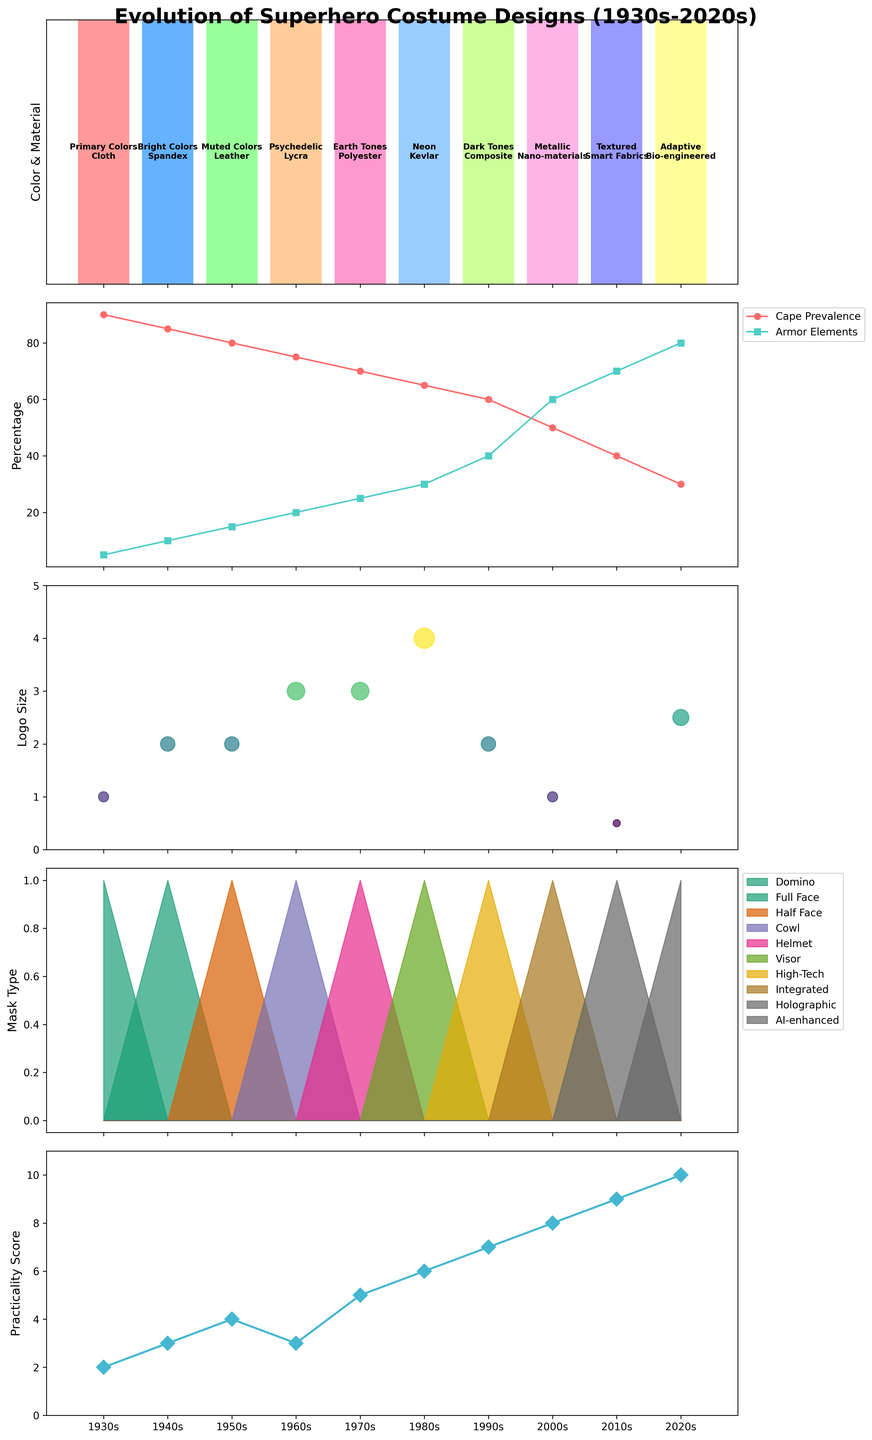How did the cape prevalence change from the 1930s to the 2020s? Observe the trend of the line representing 'Cape Prevalence' in the second subplot. The values start at 90% in the 1930s and decrease gradually by each decade, reaching 30% in the 2020s.
Answer: Decreased from 90% to 30% Which decade saw the highest increase in practical score? Look at the fifth subplot which shows 'Practicality Score'. Identify the decade with the highest rise between two adjacent data points. The practicality score rose most significantly from the 1990s to 2000s, from 7 to 8.
Answer: 1990s to 2000s Between which decades did the armor elements percentage increase the most? Examine the second subplot which shows 'Armor Elements'. The largest increase appears to be between the 1990s and 2000s, jumping from 40% to 60%.
Answer: 1990s to 2000s What is the dominant color and material for costumes in the 1970s? In the first subplot, each decade's dominant color and material are annotated in the corresponding bars. For the 1970s, the labels indicate 'Earth Tones' and 'Polyester'.
Answer: Earth Tones and Polyester What pattern do you notice in the mask types over the decades? Look at the fourth subplot which fills areas based on different mask types. Over the decades, there is a transition from Domino (1930s) to AI-enhanced (2020s), showing a trend towards more advanced technology and less of traditional mask types.
Answer: Transition to more advanced technology Identify the decade where the logo size transitioned from 'Extra Large' to 'Minimal'. Refer to the third subplot where logo sizes are illustrated. The transition from 'Extra Large' to 'Minimal' occurs between the 1980s and 2000s, but the exact change is observed in the 2000s when it becomes 'Small' and then 'Minimal' in 2010s.
Answer: 2000s to 2010s How have the dominant colors evolved from the 1930s to the 1970s? Inspect the first subplot annotations. Initially, primary and bright colors dominate (1930s, 1940s), shifting to muted colors in the 1950s, and psychedelic to earth tones through the 1960s and 1970s.
Answer: From primary/bright to earth tones In which decades did the cape prevalence and armor elements intersect? Analyze the second subplot to find where 'Cape Prevalence' and 'Armor Elements' lines cross each other. These two lines intersect in the 2000s, where cape prevalence is 50% and armor elements is 50%.
Answer: 2000s Which mask type was most prevalent in the 1960s? Look at the fourth subplot for the 1960s area fill. The 'Cowl' type is prevalent in this decade as indicated by the fill color and label.
Answer: Cowl 